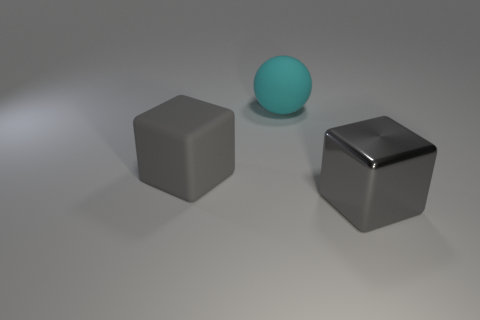Add 3 large yellow shiny cylinders. How many objects exist? 6 Subtract all balls. How many objects are left? 2 Add 2 small blue cubes. How many small blue cubes exist? 2 Subtract 1 cyan spheres. How many objects are left? 2 Subtract all big gray things. Subtract all blue matte cylinders. How many objects are left? 1 Add 1 cyan matte spheres. How many cyan matte spheres are left? 2 